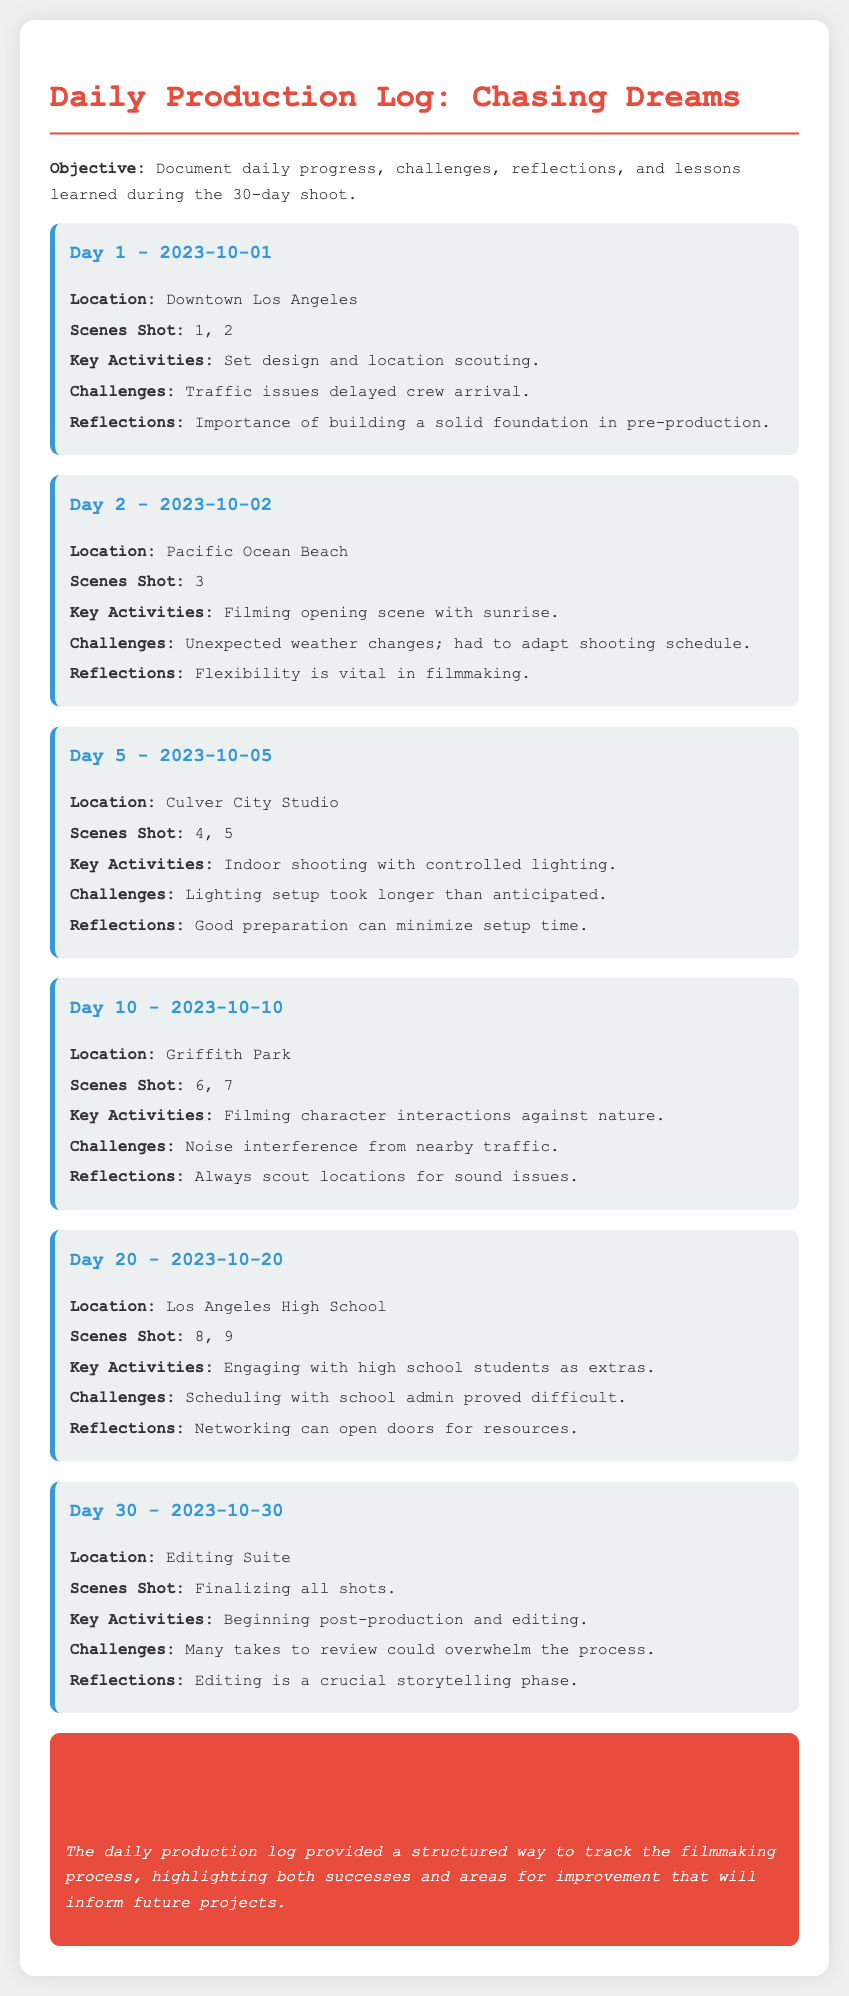what is the objective of the daily production log? The objective is to document daily progress, challenges, reflections, and lessons learned during the 30-day shoot.
Answer: Document daily progress what location was used for the beginning scene? The location for filming the opening scene was Pacific Ocean Beach.
Answer: Pacific Ocean Beach how many scenes were shot on Day 20? Two scenes were shot on Day 20.
Answer: 2 what was a challenge faced on Day 10? A challenge faced on Day 10 was noise interference from nearby traffic.
Answer: Noise interference what did the log highlight about the filmmaking process? The log highlighted both successes and areas for improvement that will inform future projects.
Answer: Successes and areas for improvement 